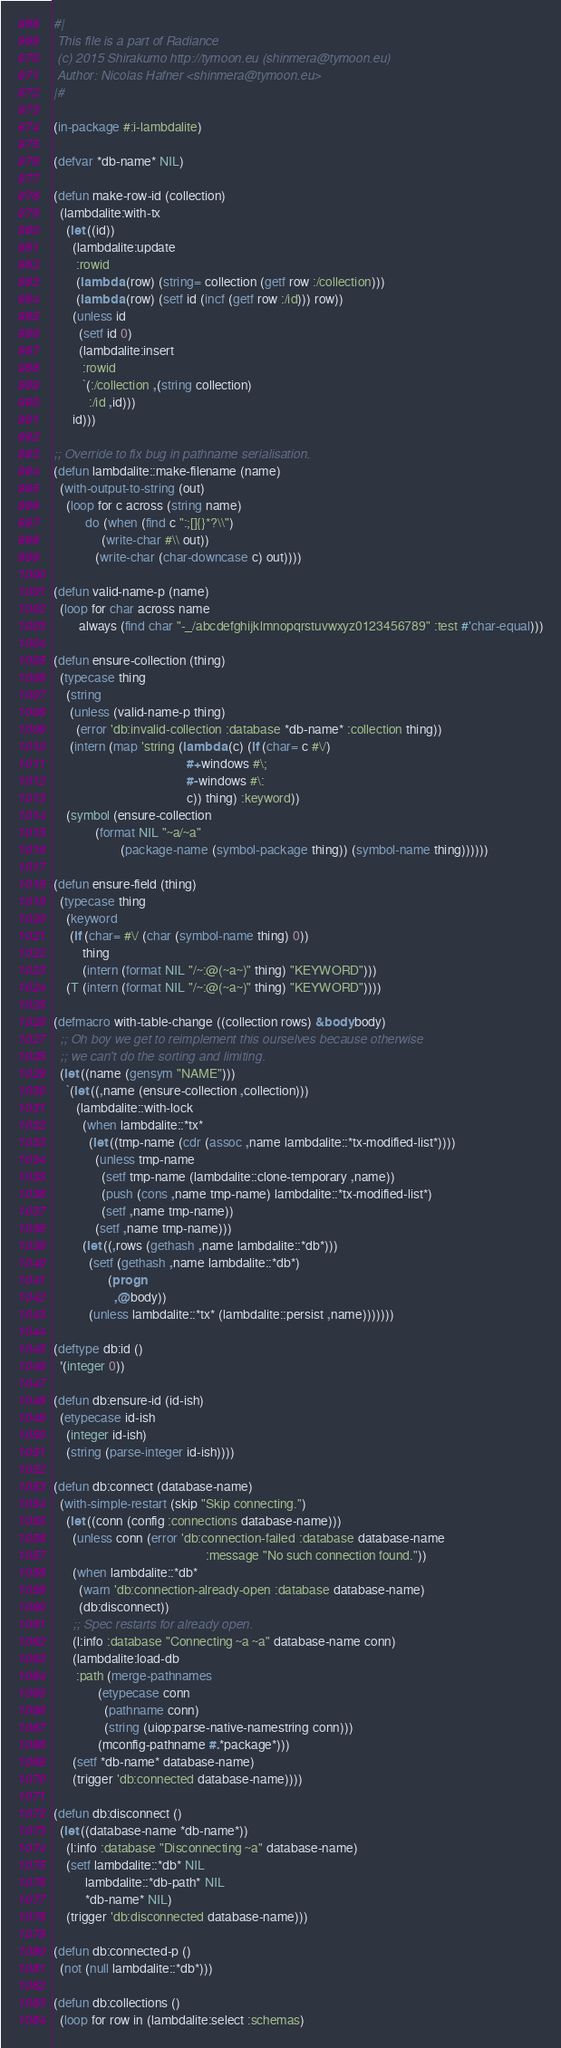<code> <loc_0><loc_0><loc_500><loc_500><_Lisp_>#|
 This file is a part of Radiance
 (c) 2015 Shirakumo http://tymoon.eu (shinmera@tymoon.eu)
 Author: Nicolas Hafner <shinmera@tymoon.eu>
|#

(in-package #:i-lambdalite)

(defvar *db-name* NIL)

(defun make-row-id (collection)
  (lambdalite:with-tx
    (let ((id))
      (lambdalite:update
       :rowid
       (lambda (row) (string= collection (getf row :/collection)))
       (lambda (row) (setf id (incf (getf row :/id))) row))
      (unless id
        (setf id 0)
        (lambdalite:insert
         :rowid
         `(:/collection ,(string collection)
           :/id ,id)))
      id)))

;; Override to fix bug in pathname serialisation.
(defun lambdalite::make-filename (name)
  (with-output-to-string (out)
    (loop for c across (string name)
          do (when (find c ":;[]{}*?\\")
               (write-char #\\ out))
             (write-char (char-downcase c) out))))

(defun valid-name-p (name)
  (loop for char across name
        always (find char "-_/abcdefghijklmnopqrstuvwxyz0123456789" :test #'char-equal)))

(defun ensure-collection (thing)
  (typecase thing
    (string
     (unless (valid-name-p thing)
       (error 'db:invalid-collection :database *db-name* :collection thing))
     (intern (map 'string (lambda (c) (if (char= c #\/)
                                          #+windows #\;
                                          #-windows #\:
                                          c)) thing) :keyword))
    (symbol (ensure-collection
             (format NIL "~a/~a"
                     (package-name (symbol-package thing)) (symbol-name thing))))))

(defun ensure-field (thing)
  (typecase thing
    (keyword
     (if (char= #\/ (char (symbol-name thing) 0))
         thing
         (intern (format NIL "/~:@(~a~)" thing) "KEYWORD")))
    (T (intern (format NIL "/~:@(~a~)" thing) "KEYWORD"))))

(defmacro with-table-change ((collection rows) &body body)
  ;; Oh boy we get to reimplement this ourselves because otherwise
  ;; we can't do the sorting and limiting.
  (let ((name (gensym "NAME")))
    `(let ((,name (ensure-collection ,collection)))
       (lambdalite::with-lock
         (when lambdalite::*tx*
           (let ((tmp-name (cdr (assoc ,name lambdalite::*tx-modified-list*)))) 
             (unless tmp-name
               (setf tmp-name (lambdalite::clone-temporary ,name))
               (push (cons ,name tmp-name) lambdalite::*tx-modified-list*)
               (setf ,name tmp-name))
             (setf ,name tmp-name)))
         (let ((,rows (gethash ,name lambdalite::*db*)))
           (setf (gethash ,name lambdalite::*db*)
                 (progn
                   ,@body))
           (unless lambdalite::*tx* (lambdalite::persist ,name)))))))

(deftype db:id ()
  '(integer 0))

(defun db:ensure-id (id-ish)
  (etypecase id-ish
    (integer id-ish)
    (string (parse-integer id-ish))))

(defun db:connect (database-name)
  (with-simple-restart (skip "Skip connecting.")
    (let ((conn (config :connections database-name)))
      (unless conn (error 'db:connection-failed :database database-name
                                                :message "No such connection found."))
      (when lambdalite::*db*
        (warn 'db:connection-already-open :database database-name)
        (db:disconnect))
      ;; Spec restarts for already open.
      (l:info :database "Connecting ~a ~a" database-name conn)
      (lambdalite:load-db
       :path (merge-pathnames
              (etypecase conn
                (pathname conn)
                (string (uiop:parse-native-namestring conn)))
              (mconfig-pathname #.*package*)))
      (setf *db-name* database-name)
      (trigger 'db:connected database-name))))

(defun db:disconnect ()
  (let ((database-name *db-name*))
    (l:info :database "Disconnecting ~a" database-name)
    (setf lambdalite::*db* NIL
          lambdalite::*db-path* NIL
          *db-name* NIL)
    (trigger 'db:disconnected database-name)))

(defun db:connected-p ()
  (not (null lambdalite::*db*)))

(defun db:collections ()
  (loop for row in (lambdalite:select :schemas)</code> 